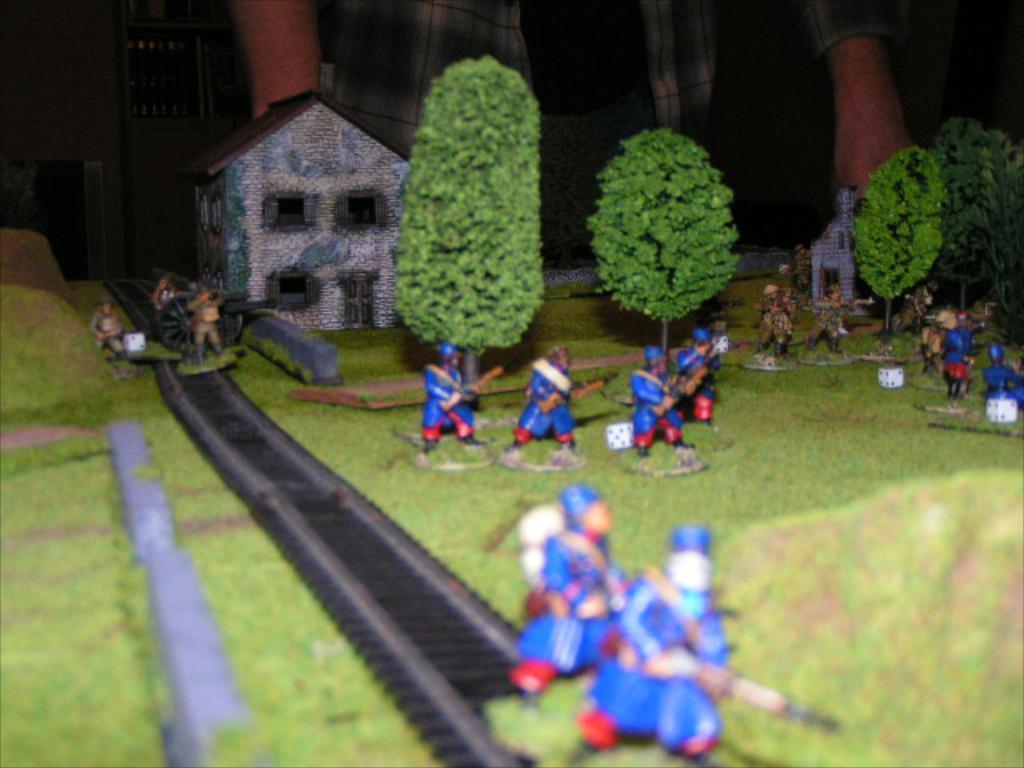Could you give a brief overview of what you see in this image? In this image we can see a model. There are people holding something. Also there is a railway track. On the track there are few people. Also there is a cannon. And there are trees and buildings. In the back there is a person. 